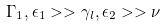<formula> <loc_0><loc_0><loc_500><loc_500>\Gamma _ { 1 } , \epsilon _ { 1 } > > \gamma _ { l } , \epsilon _ { 2 } > > \nu</formula> 